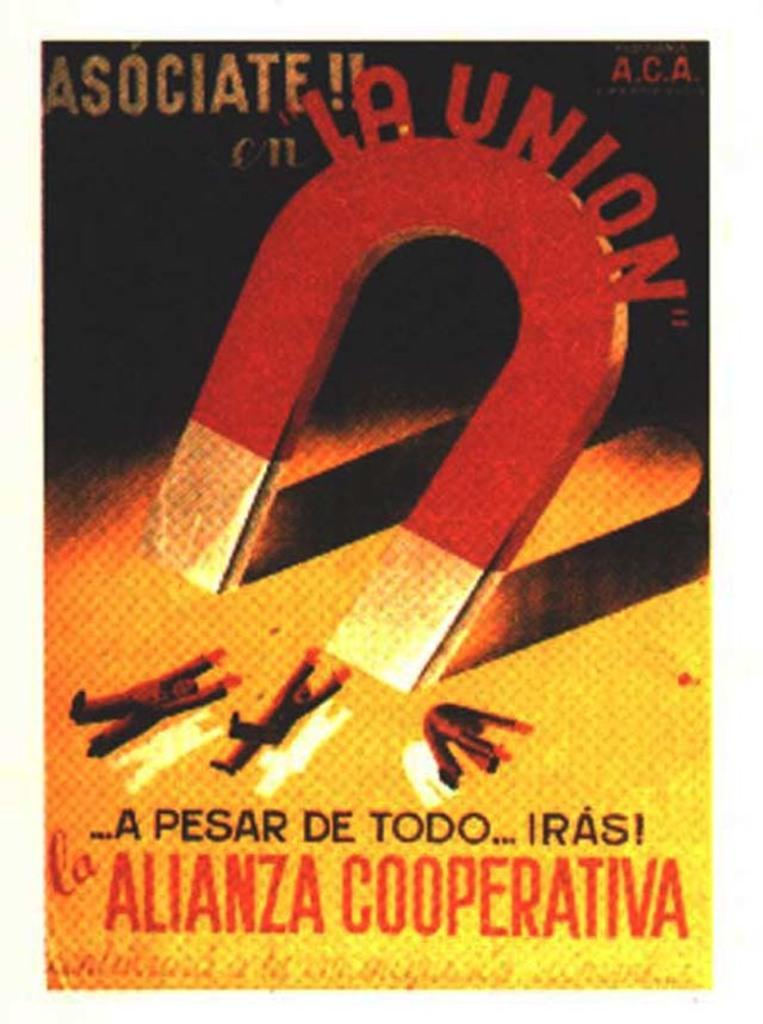<image>
Create a compact narrative representing the image presented. A poster that features a painting of a large magnet and includes the text "la union". 